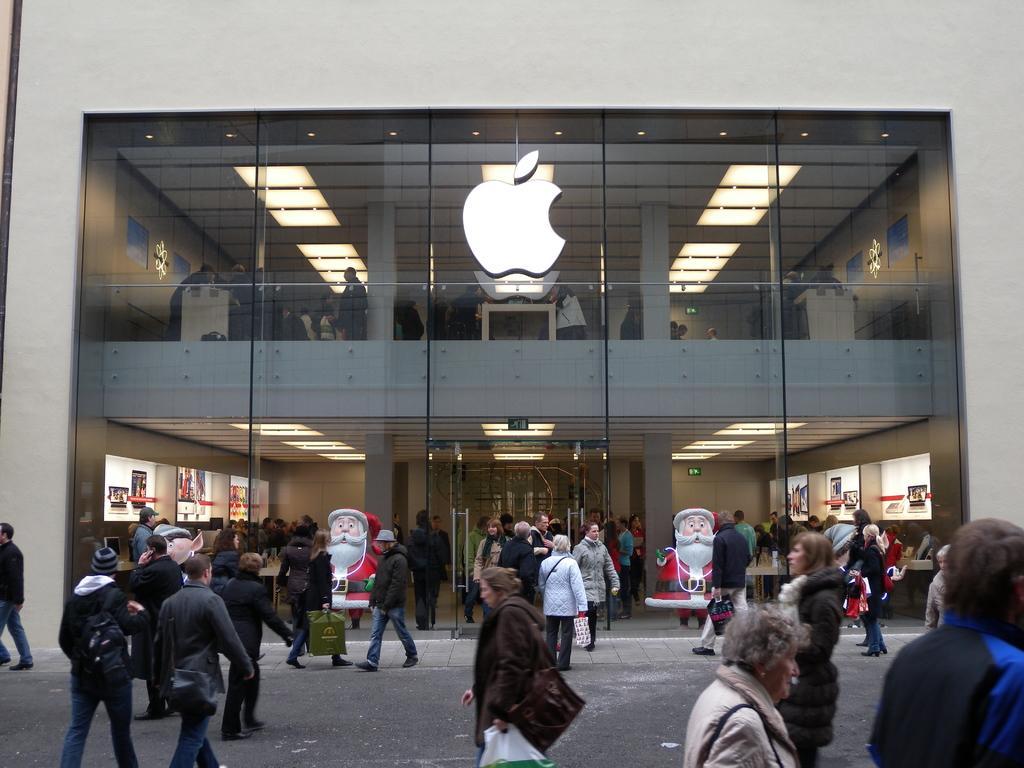How would you summarize this image in a sentence or two? On this glass wall there is an apple logo. Through this glass we can see people and lights. In-front of this glass building there are people and statues.  